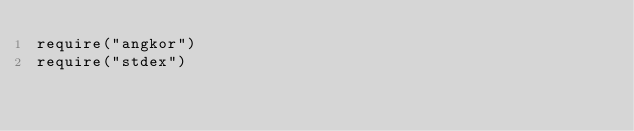<code> <loc_0><loc_0><loc_500><loc_500><_CMake_>require("angkor")
require("stdex")
</code> 